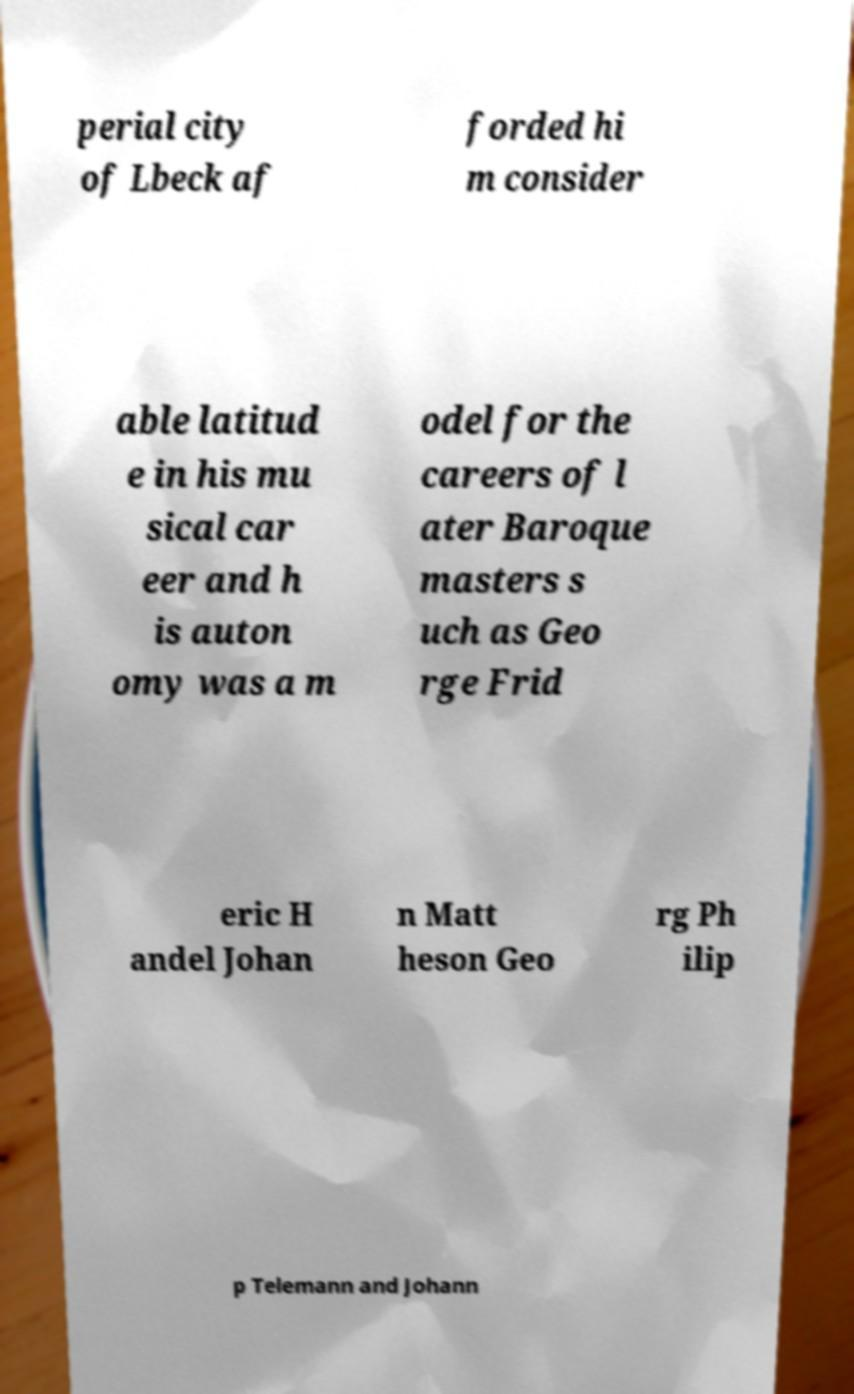Can you read and provide the text displayed in the image?This photo seems to have some interesting text. Can you extract and type it out for me? perial city of Lbeck af forded hi m consider able latitud e in his mu sical car eer and h is auton omy was a m odel for the careers of l ater Baroque masters s uch as Geo rge Frid eric H andel Johan n Matt heson Geo rg Ph ilip p Telemann and Johann 